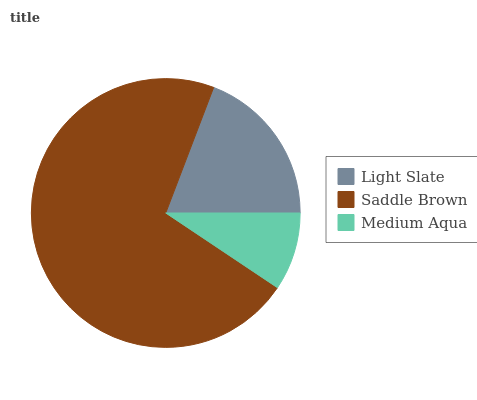Is Medium Aqua the minimum?
Answer yes or no. Yes. Is Saddle Brown the maximum?
Answer yes or no. Yes. Is Saddle Brown the minimum?
Answer yes or no. No. Is Medium Aqua the maximum?
Answer yes or no. No. Is Saddle Brown greater than Medium Aqua?
Answer yes or no. Yes. Is Medium Aqua less than Saddle Brown?
Answer yes or no. Yes. Is Medium Aqua greater than Saddle Brown?
Answer yes or no. No. Is Saddle Brown less than Medium Aqua?
Answer yes or no. No. Is Light Slate the high median?
Answer yes or no. Yes. Is Light Slate the low median?
Answer yes or no. Yes. Is Medium Aqua the high median?
Answer yes or no. No. Is Saddle Brown the low median?
Answer yes or no. No. 